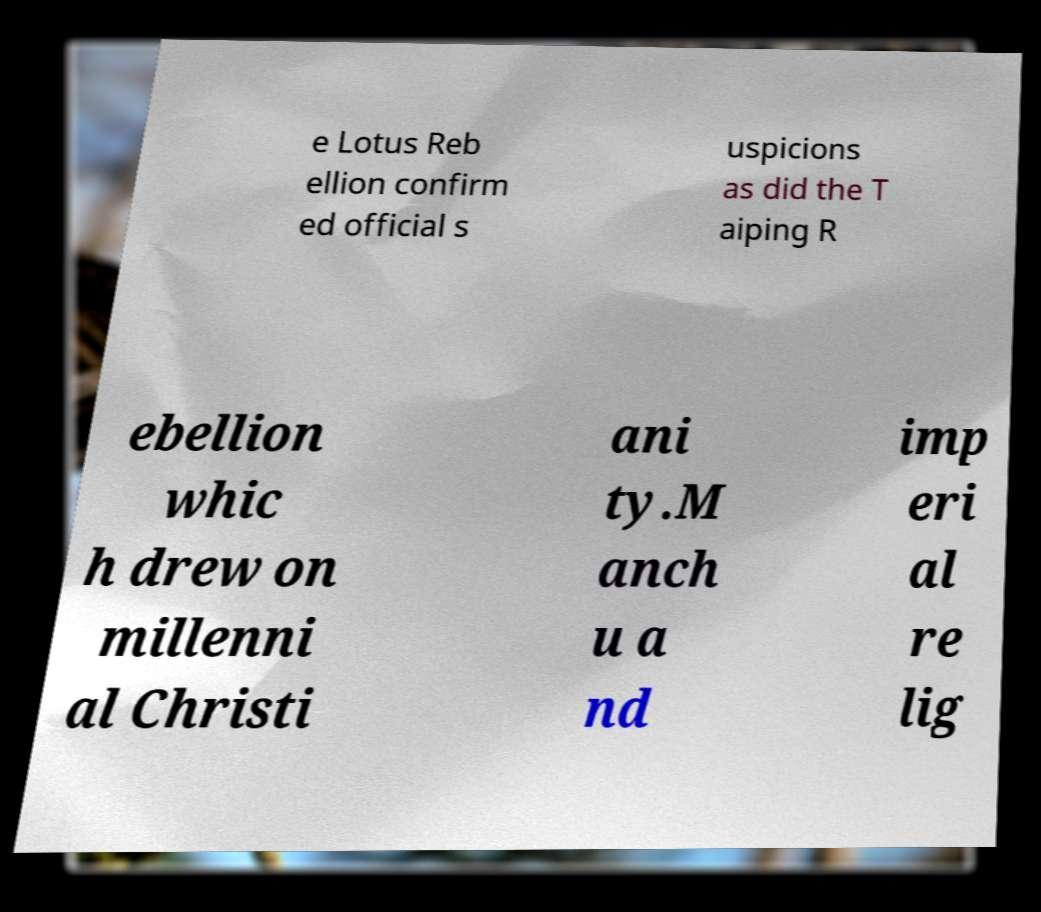What messages or text are displayed in this image? I need them in a readable, typed format. e Lotus Reb ellion confirm ed official s uspicions as did the T aiping R ebellion whic h drew on millenni al Christi ani ty.M anch u a nd imp eri al re lig 